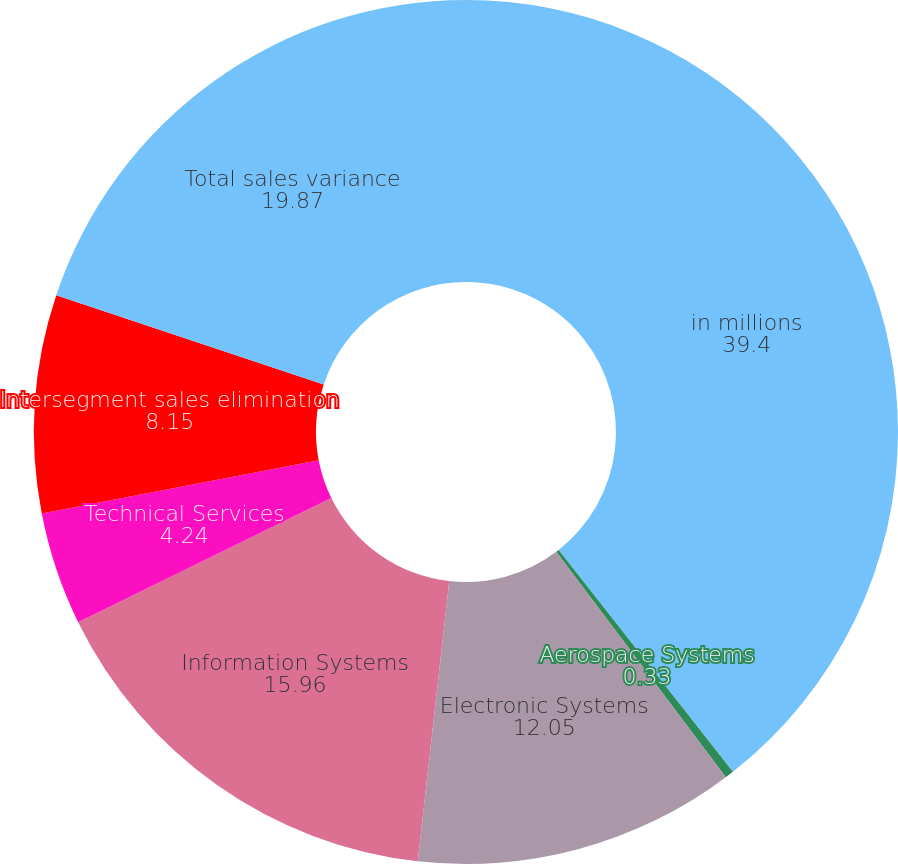Convert chart to OTSL. <chart><loc_0><loc_0><loc_500><loc_500><pie_chart><fcel>in millions<fcel>Aerospace Systems<fcel>Electronic Systems<fcel>Information Systems<fcel>Technical Services<fcel>Intersegment sales elimination<fcel>Total sales variance<nl><fcel>39.4%<fcel>0.33%<fcel>12.05%<fcel>15.96%<fcel>4.24%<fcel>8.15%<fcel>19.87%<nl></chart> 